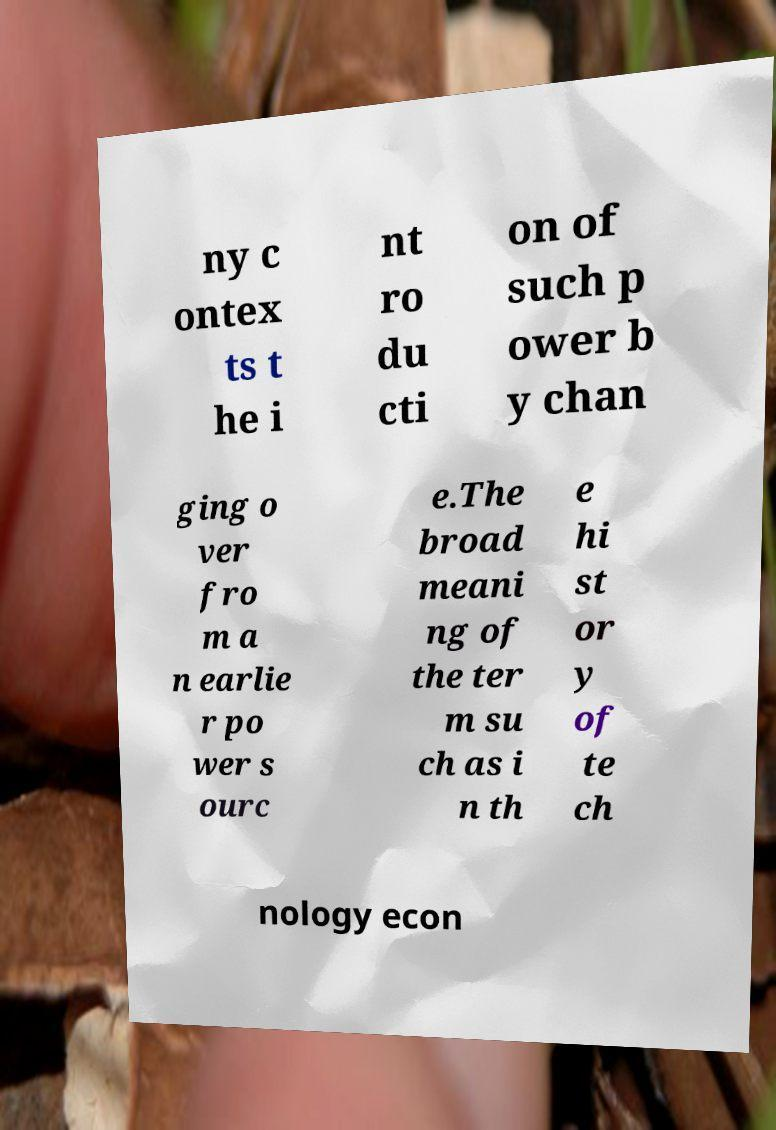Can you read and provide the text displayed in the image?This photo seems to have some interesting text. Can you extract and type it out for me? ny c ontex ts t he i nt ro du cti on of such p ower b y chan ging o ver fro m a n earlie r po wer s ourc e.The broad meani ng of the ter m su ch as i n th e hi st or y of te ch nology econ 